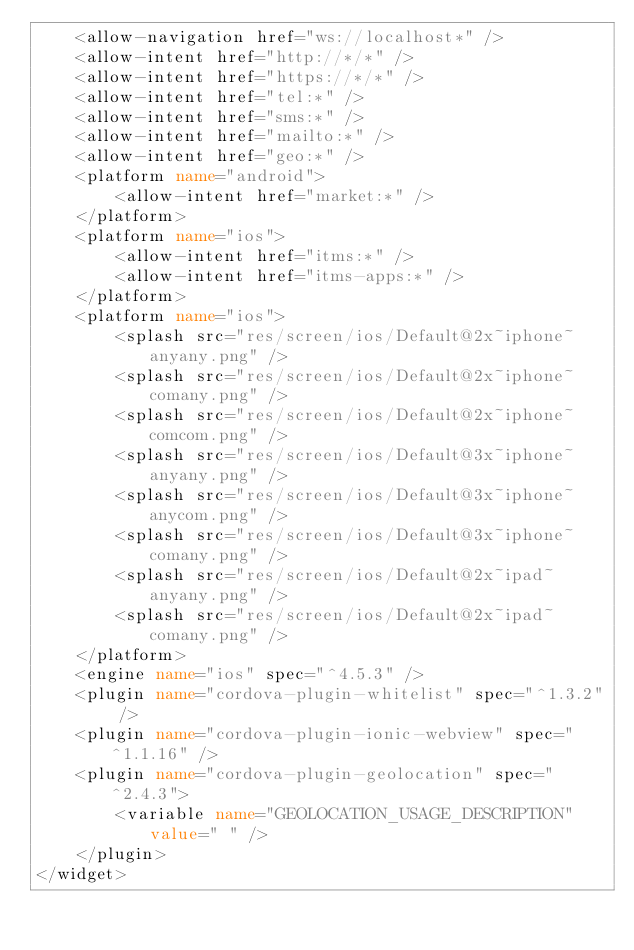<code> <loc_0><loc_0><loc_500><loc_500><_XML_>    <allow-navigation href="ws://localhost*" />
    <allow-intent href="http://*/*" />
    <allow-intent href="https://*/*" />
    <allow-intent href="tel:*" />
    <allow-intent href="sms:*" />
    <allow-intent href="mailto:*" />
    <allow-intent href="geo:*" />
    <platform name="android">
        <allow-intent href="market:*" />
    </platform>
    <platform name="ios">
        <allow-intent href="itms:*" />
        <allow-intent href="itms-apps:*" />
    </platform>
    <platform name="ios">
        <splash src="res/screen/ios/Default@2x~iphone~anyany.png" />
        <splash src="res/screen/ios/Default@2x~iphone~comany.png" />
        <splash src="res/screen/ios/Default@2x~iphone~comcom.png" />
        <splash src="res/screen/ios/Default@3x~iphone~anyany.png" />
        <splash src="res/screen/ios/Default@3x~iphone~anycom.png" />
        <splash src="res/screen/ios/Default@3x~iphone~comany.png" />
        <splash src="res/screen/ios/Default@2x~ipad~anyany.png" />
        <splash src="res/screen/ios/Default@2x~ipad~comany.png" />
    </platform>
    <engine name="ios" spec="^4.5.3" />
    <plugin name="cordova-plugin-whitelist" spec="^1.3.2" />
    <plugin name="cordova-plugin-ionic-webview" spec="^1.1.16" />
    <plugin name="cordova-plugin-geolocation" spec="^2.4.3">
        <variable name="GEOLOCATION_USAGE_DESCRIPTION" value=" " />
    </plugin>
</widget>
</code> 